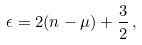<formula> <loc_0><loc_0><loc_500><loc_500>\epsilon = 2 ( n - \mu ) + \frac { 3 } { 2 } \, ,</formula> 